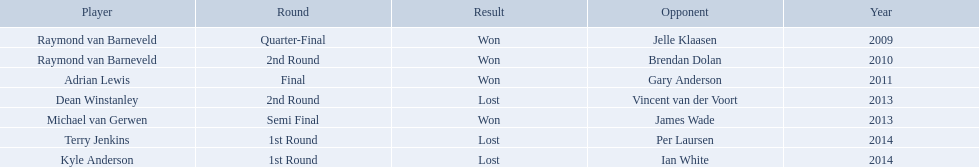Who are all the players? Raymond van Barneveld, Raymond van Barneveld, Adrian Lewis, Dean Winstanley, Michael van Gerwen, Terry Jenkins, Kyle Anderson. When did they play? 2009, 2010, 2011, 2013, 2013, 2014, 2014. And which player played in 2011? Adrian Lewis. Who are the players listed? Raymond van Barneveld, Raymond van Barneveld, Adrian Lewis, Dean Winstanley, Michael van Gerwen, Terry Jenkins, Kyle Anderson. Which of these players played in 2011? Adrian Lewis. 